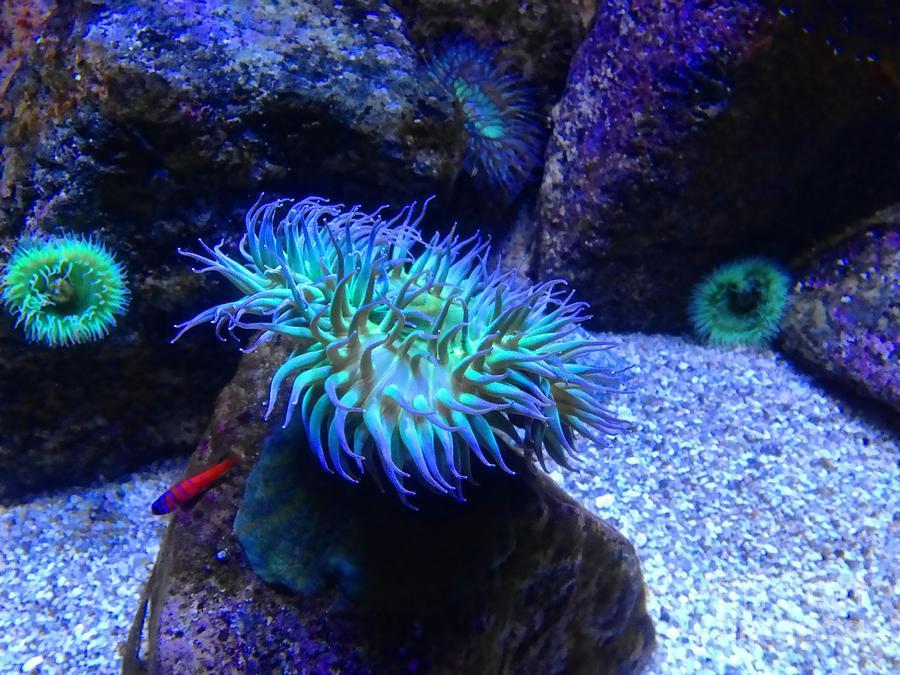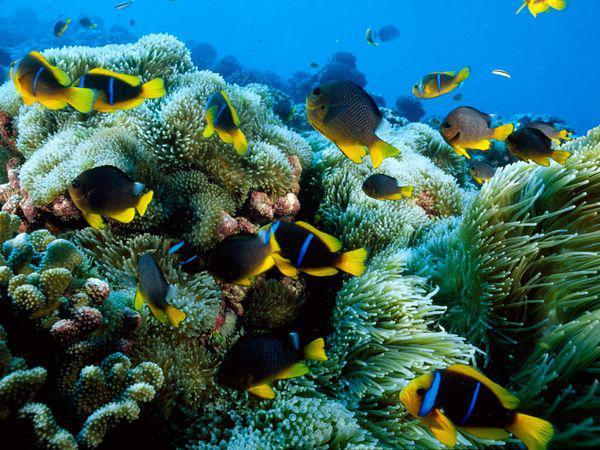The first image is the image on the left, the second image is the image on the right. Given the left and right images, does the statement "A single fish is swimming near the sea plant in the image on the left." hold true? Answer yes or no. Yes. The first image is the image on the left, the second image is the image on the right. Considering the images on both sides, is "Each image shows multiple fish with white stripes swimming above anemone tendrils, and the left image features anemone tendrils with non-tapered yellow tips." valid? Answer yes or no. No. 